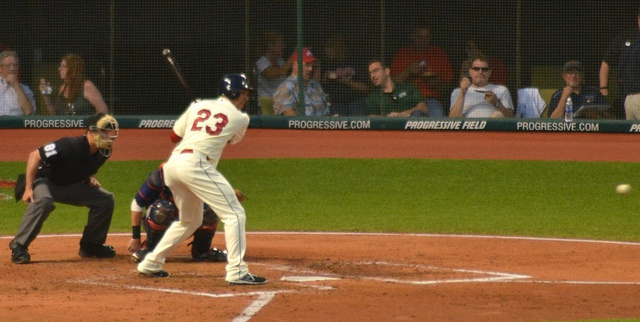Describe the objects in this image and their specific colors. I can see people in black, beige, lightyellow, gray, and tan tones, people in black, gray, and maroon tones, people in black, maroon, olive, and gray tones, people in black, maroon, gray, and darkblue tones, and people in black, darkgray, gray, and maroon tones in this image. 